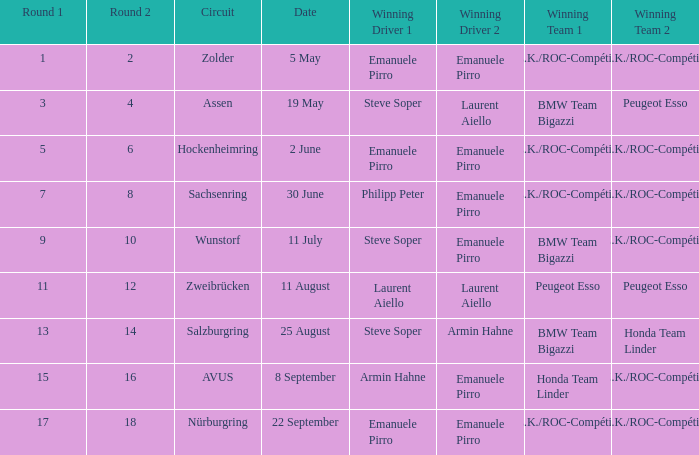Who is the winning driver of the race on 5 May? Emanuele Pirro Emanuele Pirro. 